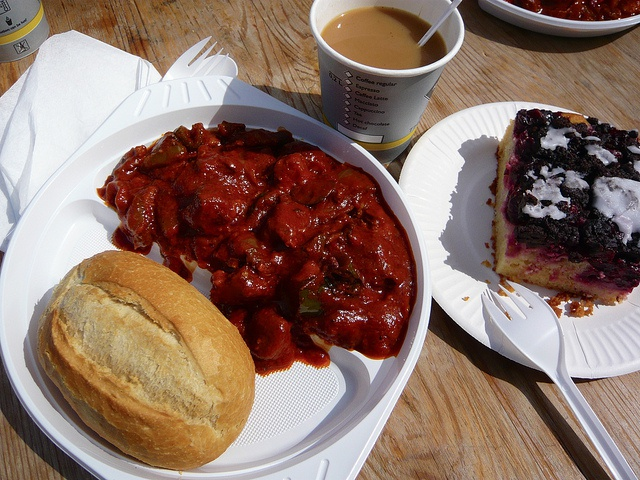Describe the objects in this image and their specific colors. I can see dining table in lightgray, black, maroon, gray, and tan tones, cake in gray, black, maroon, and darkgray tones, cup in gray, black, olive, and maroon tones, fork in gray, lightgray, and darkgray tones, and bowl in gray, black, maroon, and darkgray tones in this image. 